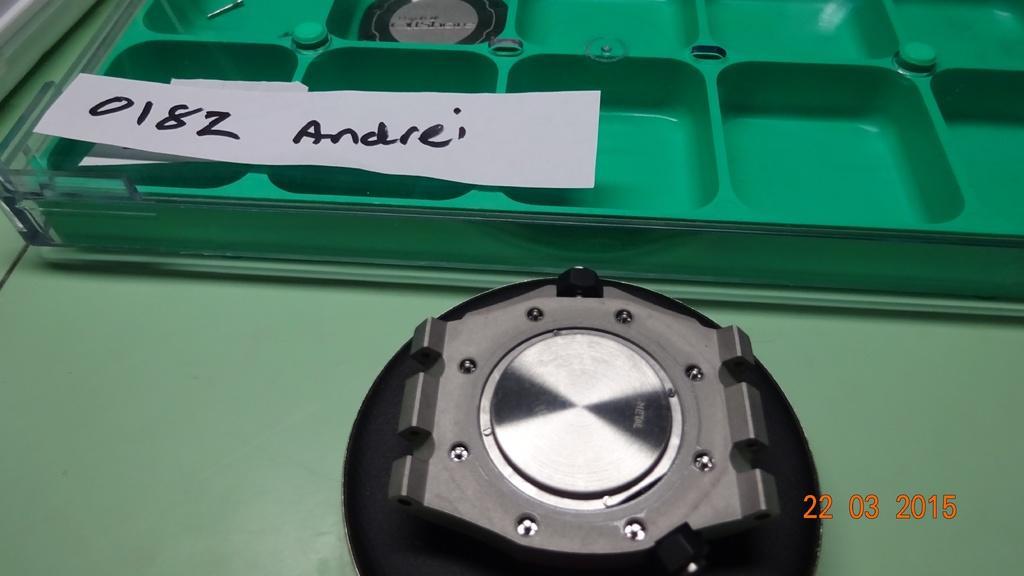Can you describe this image briefly? In this image I can see green color object and some other object over here. Here I can see a paper on which something written on it. Here I can see a watermark. 